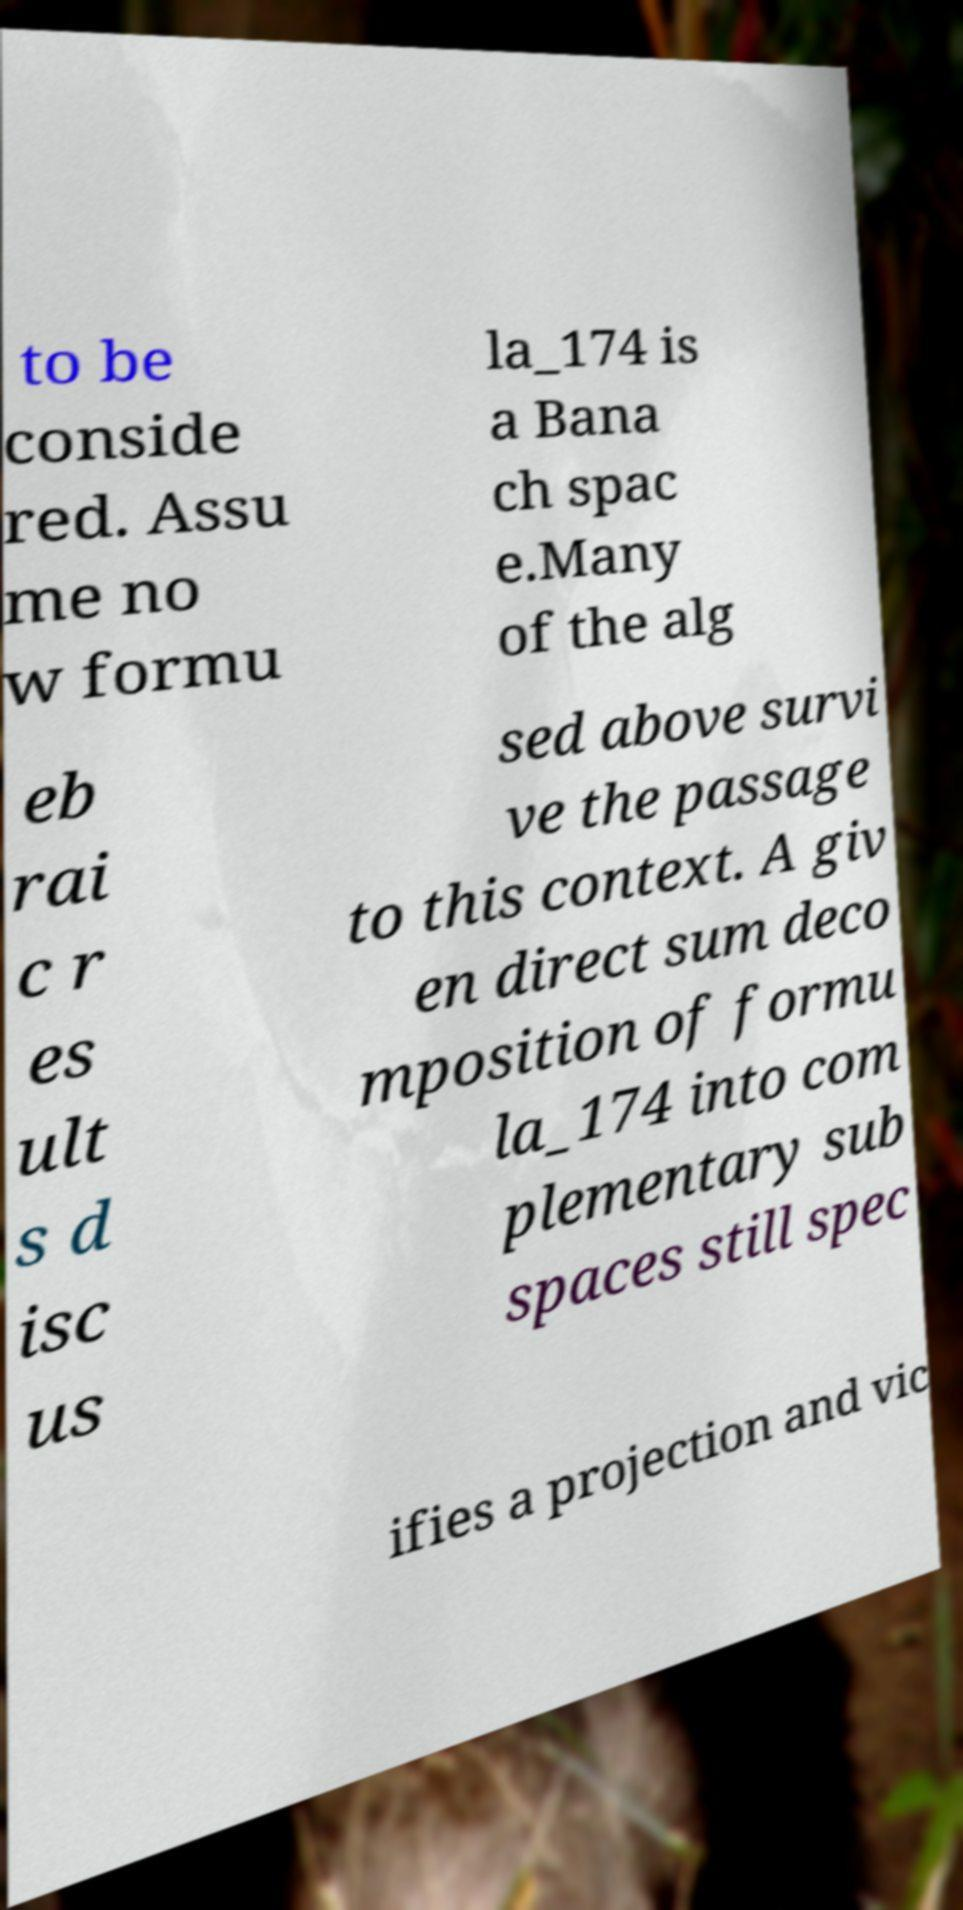Could you assist in decoding the text presented in this image and type it out clearly? to be conside red. Assu me no w formu la_174 is a Bana ch spac e.Many of the alg eb rai c r es ult s d isc us sed above survi ve the passage to this context. A giv en direct sum deco mposition of formu la_174 into com plementary sub spaces still spec ifies a projection and vic 